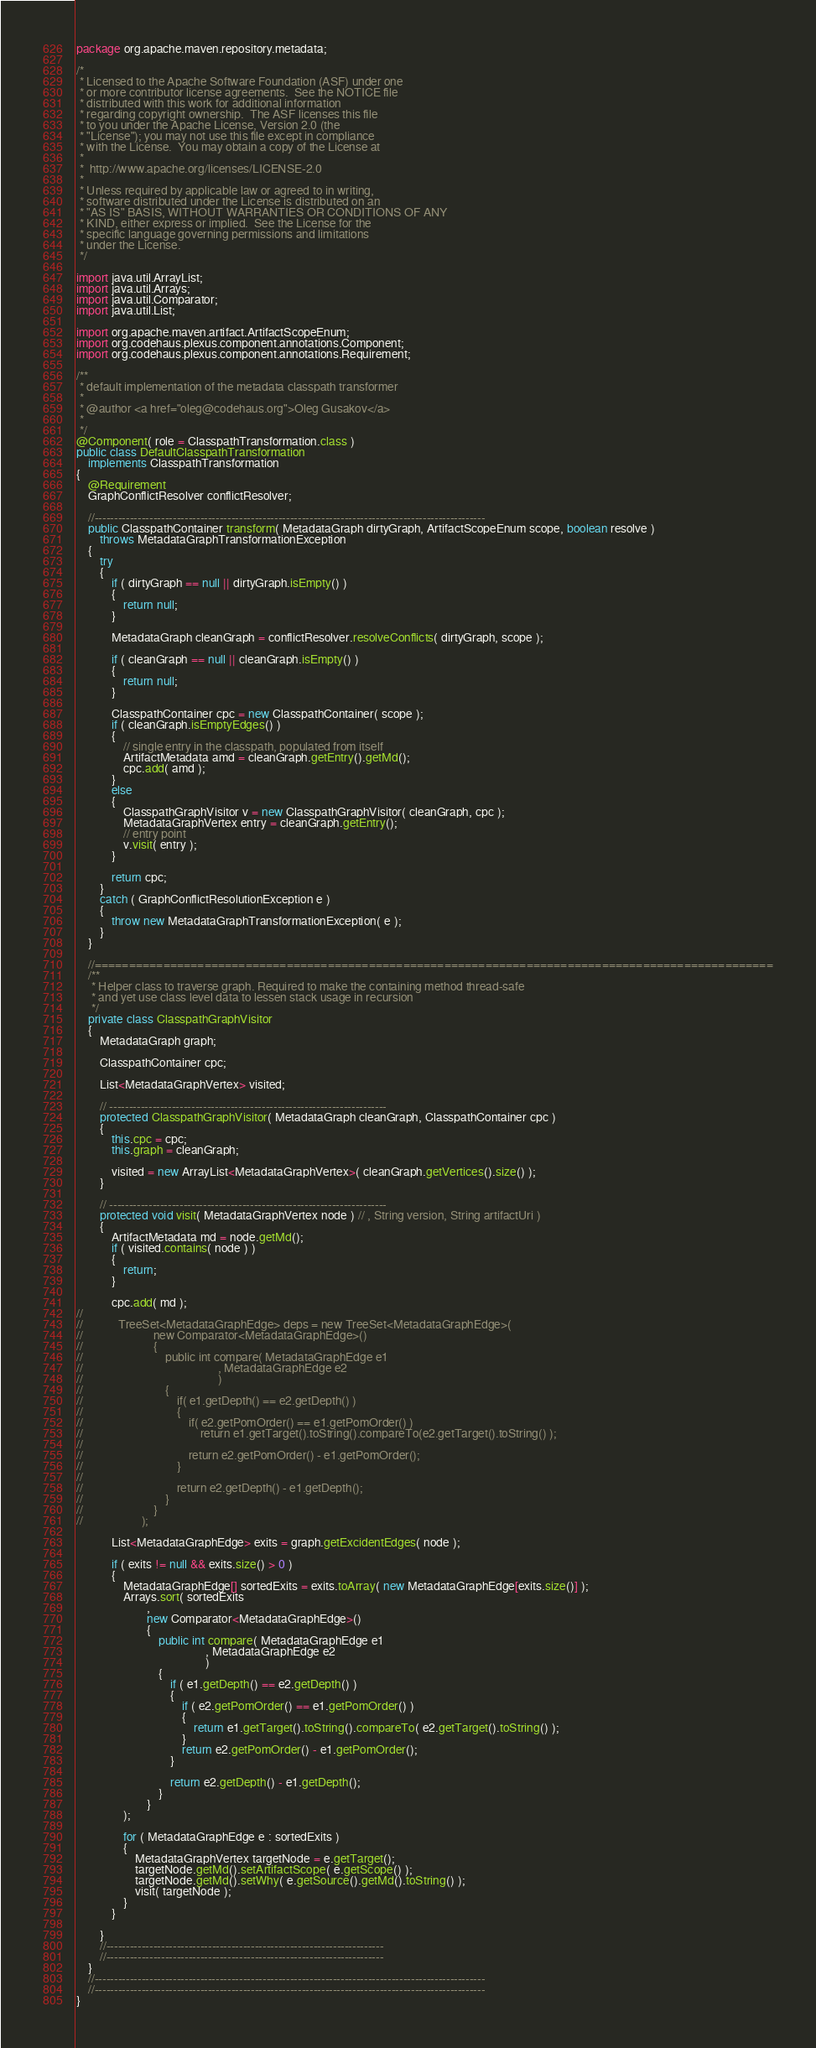<code> <loc_0><loc_0><loc_500><loc_500><_Java_>package org.apache.maven.repository.metadata;

/*
 * Licensed to the Apache Software Foundation (ASF) under one
 * or more contributor license agreements.  See the NOTICE file
 * distributed with this work for additional information
 * regarding copyright ownership.  The ASF licenses this file
 * to you under the Apache License, Version 2.0 (the
 * "License"); you may not use this file except in compliance
 * with the License.  You may obtain a copy of the License at
 *
 *  http://www.apache.org/licenses/LICENSE-2.0
 *
 * Unless required by applicable law or agreed to in writing,
 * software distributed under the License is distributed on an
 * "AS IS" BASIS, WITHOUT WARRANTIES OR CONDITIONS OF ANY
 * KIND, either express or implied.  See the License for the
 * specific language governing permissions and limitations
 * under the License.
 */

import java.util.ArrayList;
import java.util.Arrays;
import java.util.Comparator;
import java.util.List;

import org.apache.maven.artifact.ArtifactScopeEnum;
import org.codehaus.plexus.component.annotations.Component;
import org.codehaus.plexus.component.annotations.Requirement;

/**
 * default implementation of the metadata classpath transformer
 *
 * @author <a href="oleg@codehaus.org">Oleg Gusakov</a>
 *
 */
@Component( role = ClasspathTransformation.class )
public class DefaultClasspathTransformation
    implements ClasspathTransformation
{
    @Requirement
    GraphConflictResolver conflictResolver;

    //----------------------------------------------------------------------------------------------------
    public ClasspathContainer transform( MetadataGraph dirtyGraph, ArtifactScopeEnum scope, boolean resolve )
        throws MetadataGraphTransformationException
    {
        try
        {
            if ( dirtyGraph == null || dirtyGraph.isEmpty() )
            {
                return null;
            }

            MetadataGraph cleanGraph = conflictResolver.resolveConflicts( dirtyGraph, scope );

            if ( cleanGraph == null || cleanGraph.isEmpty() )
            {
                return null;
            }

            ClasspathContainer cpc = new ClasspathContainer( scope );
            if ( cleanGraph.isEmptyEdges() )
            {
                // single entry in the classpath, populated from itself
                ArtifactMetadata amd = cleanGraph.getEntry().getMd();
                cpc.add( amd );
            }
            else
            {
                ClasspathGraphVisitor v = new ClasspathGraphVisitor( cleanGraph, cpc );
                MetadataGraphVertex entry = cleanGraph.getEntry();
                // entry point
                v.visit( entry );
            }

            return cpc;
        }
        catch ( GraphConflictResolutionException e )
        {
            throw new MetadataGraphTransformationException( e );
        }
    }

    //===================================================================================================
    /**
     * Helper class to traverse graph. Required to make the containing method thread-safe
     * and yet use class level data to lessen stack usage in recursion
     */
    private class ClasspathGraphVisitor
    {
        MetadataGraph graph;

        ClasspathContainer cpc;

        List<MetadataGraphVertex> visited;

        // -----------------------------------------------------------------------
        protected ClasspathGraphVisitor( MetadataGraph cleanGraph, ClasspathContainer cpc )
        {
            this.cpc = cpc;
            this.graph = cleanGraph;

            visited = new ArrayList<MetadataGraphVertex>( cleanGraph.getVertices().size() );
        }

        // -----------------------------------------------------------------------
        protected void visit( MetadataGraphVertex node ) // , String version, String artifactUri )
        {
            ArtifactMetadata md = node.getMd();
            if ( visited.contains( node ) )
            {
                return;
            }

            cpc.add( md );
//
//            TreeSet<MetadataGraphEdge> deps = new TreeSet<MetadataGraphEdge>(
//                        new Comparator<MetadataGraphEdge>()
//                        {
//                            public int compare( MetadataGraphEdge e1
//                                              , MetadataGraphEdge e2
//                                              )
//                            {
//                                if( e1.getDepth() == e2.getDepth() )
//                                {
//                                    if( e2.getPomOrder() == e1.getPomOrder() )
//                                        return e1.getTarget().toString().compareTo(e2.getTarget().toString() );
//
//                                    return e2.getPomOrder() - e1.getPomOrder();
//                                }
//
//                                return e2.getDepth() - e1.getDepth();
//                            }
//                        }
//                    );

            List<MetadataGraphEdge> exits = graph.getExcidentEdges( node );

            if ( exits != null && exits.size() > 0 )
            {
                MetadataGraphEdge[] sortedExits = exits.toArray( new MetadataGraphEdge[exits.size()] );
                Arrays.sort( sortedExits
                        ,
                        new Comparator<MetadataGraphEdge>()
                        {
                            public int compare( MetadataGraphEdge e1
                                            , MetadataGraphEdge e2
                                            )
                            {
                                if ( e1.getDepth() == e2.getDepth() )
                                {
                                    if ( e2.getPomOrder() == e1.getPomOrder() )
                                    {
                                        return e1.getTarget().toString().compareTo( e2.getTarget().toString() );
                                    }
                                    return e2.getPomOrder() - e1.getPomOrder();
                                }

                                return e2.getDepth() - e1.getDepth();
                            }
                        }
                );

                for ( MetadataGraphEdge e : sortedExits )
                {
                    MetadataGraphVertex targetNode = e.getTarget();
                    targetNode.getMd().setArtifactScope( e.getScope() );
                    targetNode.getMd().setWhy( e.getSource().getMd().toString() );
                    visit( targetNode );
                }
            }

        }
        //-----------------------------------------------------------------------
        //-----------------------------------------------------------------------
    }
    //----------------------------------------------------------------------------------------------------
    //----------------------------------------------------------------------------------------------------
}



</code> 